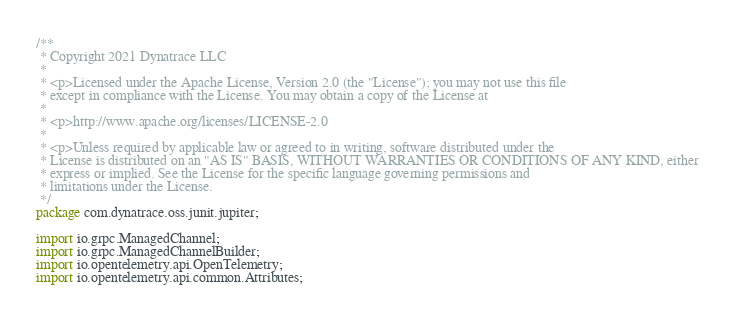Convert code to text. <code><loc_0><loc_0><loc_500><loc_500><_Java_>/**
 * Copyright 2021 Dynatrace LLC
 *
 * <p>Licensed under the Apache License, Version 2.0 (the "License"); you may not use this file
 * except in compliance with the License. You may obtain a copy of the License at
 *
 * <p>http://www.apache.org/licenses/LICENSE-2.0
 *
 * <p>Unless required by applicable law or agreed to in writing, software distributed under the
 * License is distributed on an "AS IS" BASIS, WITHOUT WARRANTIES OR CONDITIONS OF ANY KIND, either
 * express or implied. See the License for the specific language governing permissions and
 * limitations under the License.
 */
package com.dynatrace.oss.junit.jupiter;

import io.grpc.ManagedChannel;
import io.grpc.ManagedChannelBuilder;
import io.opentelemetry.api.OpenTelemetry;
import io.opentelemetry.api.common.Attributes;</code> 